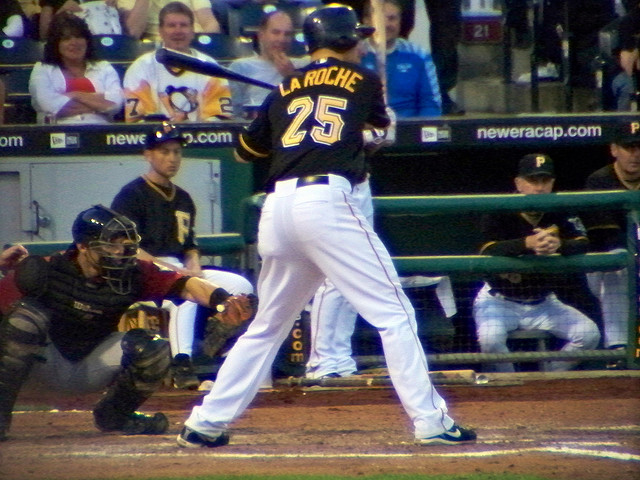Read and extract the text from this image. ROCHE 25 neweracap.com 21 P P F 2 7 om 